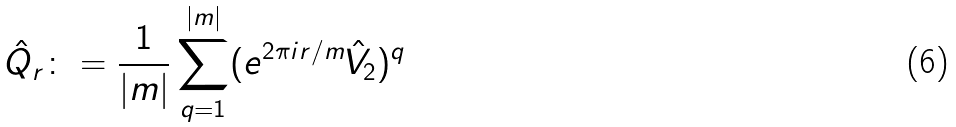<formula> <loc_0><loc_0><loc_500><loc_500>\hat { Q } _ { r } \colon = \frac { 1 } { | m | } \sum _ { q = 1 } ^ { | m | } ( e ^ { 2 \pi i r / m } \hat { V } _ { 2 } ) ^ { q }</formula> 